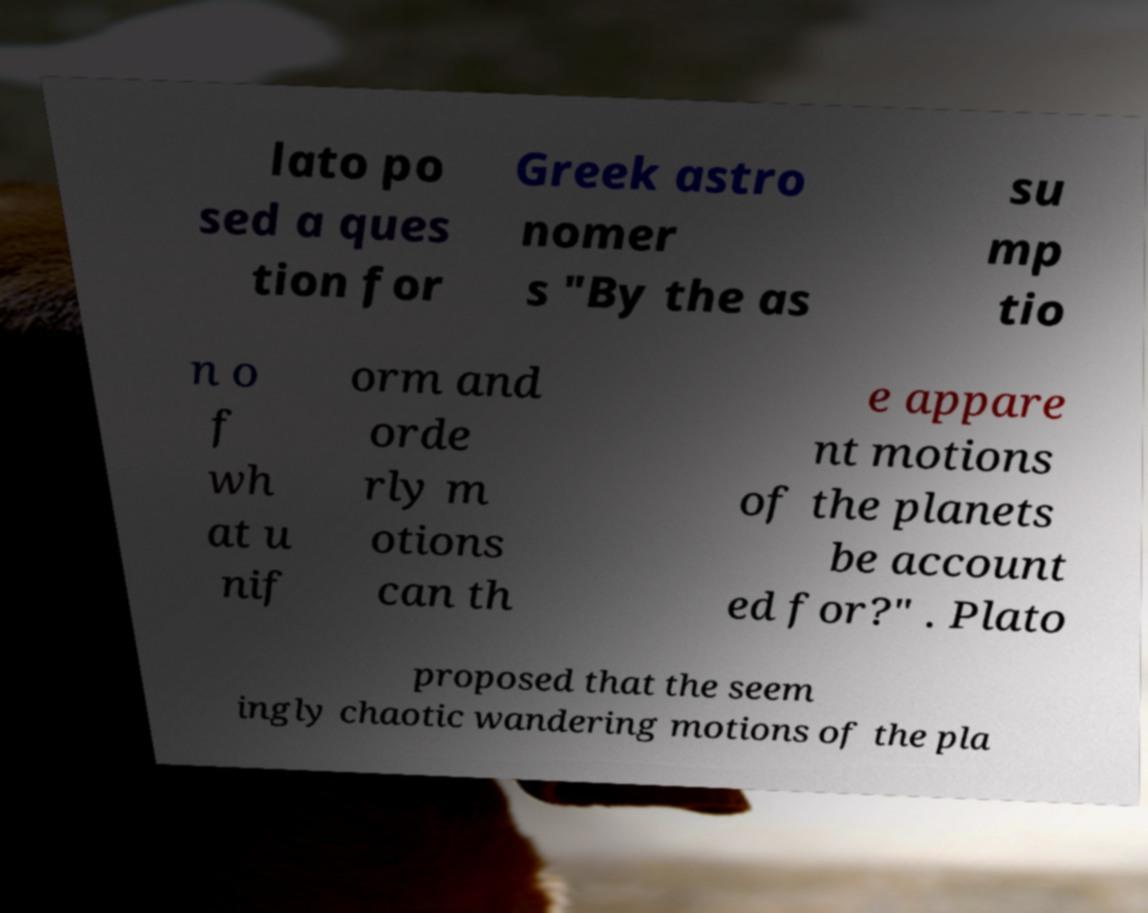Can you read and provide the text displayed in the image?This photo seems to have some interesting text. Can you extract and type it out for me? lato po sed a ques tion for Greek astro nomer s "By the as su mp tio n o f wh at u nif orm and orde rly m otions can th e appare nt motions of the planets be account ed for?" . Plato proposed that the seem ingly chaotic wandering motions of the pla 